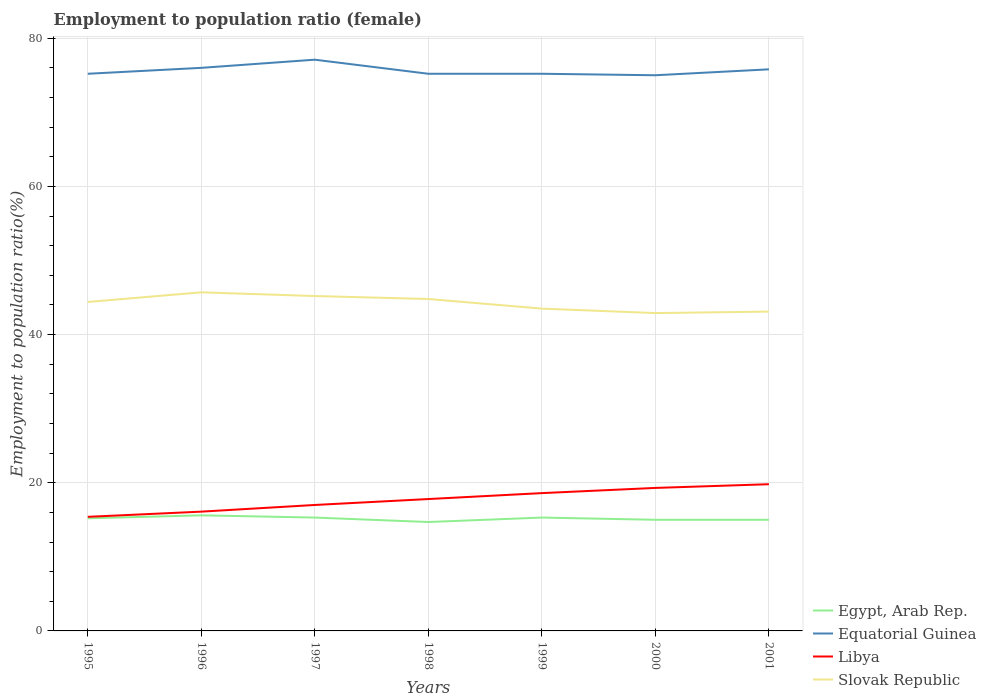How many different coloured lines are there?
Your answer should be compact. 4. Does the line corresponding to Slovak Republic intersect with the line corresponding to Equatorial Guinea?
Your response must be concise. No. Is the number of lines equal to the number of legend labels?
Your response must be concise. Yes. Across all years, what is the maximum employment to population ratio in Libya?
Keep it short and to the point. 15.4. In which year was the employment to population ratio in Libya maximum?
Ensure brevity in your answer.  1995. What is the total employment to population ratio in Equatorial Guinea in the graph?
Provide a succinct answer. 0.2. What is the difference between the highest and the second highest employment to population ratio in Egypt, Arab Rep.?
Your response must be concise. 0.9. What is the difference between the highest and the lowest employment to population ratio in Egypt, Arab Rep.?
Provide a short and direct response. 4. How many lines are there?
Your answer should be very brief. 4. What is the difference between two consecutive major ticks on the Y-axis?
Keep it short and to the point. 20. Are the values on the major ticks of Y-axis written in scientific E-notation?
Offer a very short reply. No. Does the graph contain grids?
Keep it short and to the point. Yes. Where does the legend appear in the graph?
Your answer should be compact. Bottom right. What is the title of the graph?
Your answer should be very brief. Employment to population ratio (female). What is the label or title of the X-axis?
Your answer should be very brief. Years. What is the Employment to population ratio(%) in Egypt, Arab Rep. in 1995?
Provide a short and direct response. 15.2. What is the Employment to population ratio(%) in Equatorial Guinea in 1995?
Provide a short and direct response. 75.2. What is the Employment to population ratio(%) in Libya in 1995?
Provide a short and direct response. 15.4. What is the Employment to population ratio(%) of Slovak Republic in 1995?
Offer a very short reply. 44.4. What is the Employment to population ratio(%) of Egypt, Arab Rep. in 1996?
Offer a very short reply. 15.6. What is the Employment to population ratio(%) in Libya in 1996?
Ensure brevity in your answer.  16.1. What is the Employment to population ratio(%) of Slovak Republic in 1996?
Your response must be concise. 45.7. What is the Employment to population ratio(%) in Egypt, Arab Rep. in 1997?
Ensure brevity in your answer.  15.3. What is the Employment to population ratio(%) of Equatorial Guinea in 1997?
Your response must be concise. 77.1. What is the Employment to population ratio(%) of Slovak Republic in 1997?
Your response must be concise. 45.2. What is the Employment to population ratio(%) in Egypt, Arab Rep. in 1998?
Give a very brief answer. 14.7. What is the Employment to population ratio(%) of Equatorial Guinea in 1998?
Provide a short and direct response. 75.2. What is the Employment to population ratio(%) in Libya in 1998?
Your response must be concise. 17.8. What is the Employment to population ratio(%) in Slovak Republic in 1998?
Make the answer very short. 44.8. What is the Employment to population ratio(%) of Egypt, Arab Rep. in 1999?
Provide a short and direct response. 15.3. What is the Employment to population ratio(%) of Equatorial Guinea in 1999?
Your answer should be compact. 75.2. What is the Employment to population ratio(%) in Libya in 1999?
Your answer should be compact. 18.6. What is the Employment to population ratio(%) of Slovak Republic in 1999?
Offer a very short reply. 43.5. What is the Employment to population ratio(%) in Libya in 2000?
Provide a succinct answer. 19.3. What is the Employment to population ratio(%) of Slovak Republic in 2000?
Your answer should be very brief. 42.9. What is the Employment to population ratio(%) in Egypt, Arab Rep. in 2001?
Offer a very short reply. 15. What is the Employment to population ratio(%) in Equatorial Guinea in 2001?
Make the answer very short. 75.8. What is the Employment to population ratio(%) in Libya in 2001?
Offer a very short reply. 19.8. What is the Employment to population ratio(%) in Slovak Republic in 2001?
Your answer should be very brief. 43.1. Across all years, what is the maximum Employment to population ratio(%) of Egypt, Arab Rep.?
Offer a very short reply. 15.6. Across all years, what is the maximum Employment to population ratio(%) in Equatorial Guinea?
Offer a terse response. 77.1. Across all years, what is the maximum Employment to population ratio(%) of Libya?
Give a very brief answer. 19.8. Across all years, what is the maximum Employment to population ratio(%) of Slovak Republic?
Provide a succinct answer. 45.7. Across all years, what is the minimum Employment to population ratio(%) of Egypt, Arab Rep.?
Make the answer very short. 14.7. Across all years, what is the minimum Employment to population ratio(%) in Equatorial Guinea?
Offer a very short reply. 75. Across all years, what is the minimum Employment to population ratio(%) in Libya?
Your answer should be compact. 15.4. Across all years, what is the minimum Employment to population ratio(%) in Slovak Republic?
Ensure brevity in your answer.  42.9. What is the total Employment to population ratio(%) in Egypt, Arab Rep. in the graph?
Provide a succinct answer. 106.1. What is the total Employment to population ratio(%) in Equatorial Guinea in the graph?
Make the answer very short. 529.5. What is the total Employment to population ratio(%) in Libya in the graph?
Provide a short and direct response. 124. What is the total Employment to population ratio(%) in Slovak Republic in the graph?
Make the answer very short. 309.6. What is the difference between the Employment to population ratio(%) of Egypt, Arab Rep. in 1995 and that in 1996?
Your response must be concise. -0.4. What is the difference between the Employment to population ratio(%) of Libya in 1995 and that in 1996?
Provide a succinct answer. -0.7. What is the difference between the Employment to population ratio(%) of Egypt, Arab Rep. in 1995 and that in 1997?
Give a very brief answer. -0.1. What is the difference between the Employment to population ratio(%) of Equatorial Guinea in 1995 and that in 1997?
Offer a very short reply. -1.9. What is the difference between the Employment to population ratio(%) in Libya in 1995 and that in 1997?
Ensure brevity in your answer.  -1.6. What is the difference between the Employment to population ratio(%) in Slovak Republic in 1995 and that in 1997?
Provide a succinct answer. -0.8. What is the difference between the Employment to population ratio(%) of Slovak Republic in 1995 and that in 1998?
Keep it short and to the point. -0.4. What is the difference between the Employment to population ratio(%) of Equatorial Guinea in 1995 and that in 1999?
Your response must be concise. 0. What is the difference between the Employment to population ratio(%) of Egypt, Arab Rep. in 1995 and that in 2000?
Offer a terse response. 0.2. What is the difference between the Employment to population ratio(%) in Equatorial Guinea in 1995 and that in 2000?
Give a very brief answer. 0.2. What is the difference between the Employment to population ratio(%) of Libya in 1995 and that in 2000?
Your answer should be compact. -3.9. What is the difference between the Employment to population ratio(%) in Slovak Republic in 1995 and that in 2000?
Keep it short and to the point. 1.5. What is the difference between the Employment to population ratio(%) of Equatorial Guinea in 1996 and that in 1997?
Ensure brevity in your answer.  -1.1. What is the difference between the Employment to population ratio(%) of Libya in 1996 and that in 1997?
Ensure brevity in your answer.  -0.9. What is the difference between the Employment to population ratio(%) in Slovak Republic in 1996 and that in 1997?
Your answer should be compact. 0.5. What is the difference between the Employment to population ratio(%) in Egypt, Arab Rep. in 1996 and that in 1998?
Offer a terse response. 0.9. What is the difference between the Employment to population ratio(%) in Equatorial Guinea in 1996 and that in 1998?
Make the answer very short. 0.8. What is the difference between the Employment to population ratio(%) of Libya in 1996 and that in 1999?
Your response must be concise. -2.5. What is the difference between the Employment to population ratio(%) of Slovak Republic in 1996 and that in 1999?
Provide a short and direct response. 2.2. What is the difference between the Employment to population ratio(%) in Egypt, Arab Rep. in 1996 and that in 2000?
Provide a succinct answer. 0.6. What is the difference between the Employment to population ratio(%) in Libya in 1996 and that in 2000?
Your response must be concise. -3.2. What is the difference between the Employment to population ratio(%) of Slovak Republic in 1996 and that in 2000?
Give a very brief answer. 2.8. What is the difference between the Employment to population ratio(%) in Egypt, Arab Rep. in 1996 and that in 2001?
Offer a terse response. 0.6. What is the difference between the Employment to population ratio(%) in Equatorial Guinea in 1996 and that in 2001?
Your answer should be very brief. 0.2. What is the difference between the Employment to population ratio(%) of Libya in 1996 and that in 2001?
Provide a succinct answer. -3.7. What is the difference between the Employment to population ratio(%) in Equatorial Guinea in 1997 and that in 1998?
Your response must be concise. 1.9. What is the difference between the Employment to population ratio(%) in Equatorial Guinea in 1997 and that in 1999?
Offer a very short reply. 1.9. What is the difference between the Employment to population ratio(%) in Libya in 1997 and that in 2000?
Offer a terse response. -2.3. What is the difference between the Employment to population ratio(%) of Slovak Republic in 1997 and that in 2000?
Ensure brevity in your answer.  2.3. What is the difference between the Employment to population ratio(%) of Equatorial Guinea in 1997 and that in 2001?
Your response must be concise. 1.3. What is the difference between the Employment to population ratio(%) in Egypt, Arab Rep. in 1998 and that in 1999?
Keep it short and to the point. -0.6. What is the difference between the Employment to population ratio(%) in Equatorial Guinea in 1998 and that in 1999?
Keep it short and to the point. 0. What is the difference between the Employment to population ratio(%) of Slovak Republic in 1998 and that in 2000?
Provide a succinct answer. 1.9. What is the difference between the Employment to population ratio(%) in Equatorial Guinea in 1998 and that in 2001?
Ensure brevity in your answer.  -0.6. What is the difference between the Employment to population ratio(%) of Libya in 1998 and that in 2001?
Your answer should be compact. -2. What is the difference between the Employment to population ratio(%) in Egypt, Arab Rep. in 1999 and that in 2000?
Ensure brevity in your answer.  0.3. What is the difference between the Employment to population ratio(%) in Equatorial Guinea in 1999 and that in 2000?
Offer a very short reply. 0.2. What is the difference between the Employment to population ratio(%) in Libya in 1999 and that in 2001?
Keep it short and to the point. -1.2. What is the difference between the Employment to population ratio(%) of Slovak Republic in 1999 and that in 2001?
Your response must be concise. 0.4. What is the difference between the Employment to population ratio(%) in Egypt, Arab Rep. in 2000 and that in 2001?
Your response must be concise. 0. What is the difference between the Employment to population ratio(%) in Equatorial Guinea in 2000 and that in 2001?
Provide a short and direct response. -0.8. What is the difference between the Employment to population ratio(%) of Slovak Republic in 2000 and that in 2001?
Offer a very short reply. -0.2. What is the difference between the Employment to population ratio(%) in Egypt, Arab Rep. in 1995 and the Employment to population ratio(%) in Equatorial Guinea in 1996?
Keep it short and to the point. -60.8. What is the difference between the Employment to population ratio(%) of Egypt, Arab Rep. in 1995 and the Employment to population ratio(%) of Slovak Republic in 1996?
Provide a short and direct response. -30.5. What is the difference between the Employment to population ratio(%) in Equatorial Guinea in 1995 and the Employment to population ratio(%) in Libya in 1996?
Keep it short and to the point. 59.1. What is the difference between the Employment to population ratio(%) in Equatorial Guinea in 1995 and the Employment to population ratio(%) in Slovak Republic in 1996?
Provide a succinct answer. 29.5. What is the difference between the Employment to population ratio(%) of Libya in 1995 and the Employment to population ratio(%) of Slovak Republic in 1996?
Offer a terse response. -30.3. What is the difference between the Employment to population ratio(%) in Egypt, Arab Rep. in 1995 and the Employment to population ratio(%) in Equatorial Guinea in 1997?
Offer a very short reply. -61.9. What is the difference between the Employment to population ratio(%) of Egypt, Arab Rep. in 1995 and the Employment to population ratio(%) of Slovak Republic in 1997?
Provide a short and direct response. -30. What is the difference between the Employment to population ratio(%) of Equatorial Guinea in 1995 and the Employment to population ratio(%) of Libya in 1997?
Ensure brevity in your answer.  58.2. What is the difference between the Employment to population ratio(%) in Libya in 1995 and the Employment to population ratio(%) in Slovak Republic in 1997?
Give a very brief answer. -29.8. What is the difference between the Employment to population ratio(%) in Egypt, Arab Rep. in 1995 and the Employment to population ratio(%) in Equatorial Guinea in 1998?
Give a very brief answer. -60. What is the difference between the Employment to population ratio(%) of Egypt, Arab Rep. in 1995 and the Employment to population ratio(%) of Slovak Republic in 1998?
Give a very brief answer. -29.6. What is the difference between the Employment to population ratio(%) of Equatorial Guinea in 1995 and the Employment to population ratio(%) of Libya in 1998?
Your response must be concise. 57.4. What is the difference between the Employment to population ratio(%) of Equatorial Guinea in 1995 and the Employment to population ratio(%) of Slovak Republic in 1998?
Your answer should be compact. 30.4. What is the difference between the Employment to population ratio(%) in Libya in 1995 and the Employment to population ratio(%) in Slovak Republic in 1998?
Provide a short and direct response. -29.4. What is the difference between the Employment to population ratio(%) of Egypt, Arab Rep. in 1995 and the Employment to population ratio(%) of Equatorial Guinea in 1999?
Offer a terse response. -60. What is the difference between the Employment to population ratio(%) in Egypt, Arab Rep. in 1995 and the Employment to population ratio(%) in Slovak Republic in 1999?
Ensure brevity in your answer.  -28.3. What is the difference between the Employment to population ratio(%) of Equatorial Guinea in 1995 and the Employment to population ratio(%) of Libya in 1999?
Make the answer very short. 56.6. What is the difference between the Employment to population ratio(%) of Equatorial Guinea in 1995 and the Employment to population ratio(%) of Slovak Republic in 1999?
Give a very brief answer. 31.7. What is the difference between the Employment to population ratio(%) in Libya in 1995 and the Employment to population ratio(%) in Slovak Republic in 1999?
Ensure brevity in your answer.  -28.1. What is the difference between the Employment to population ratio(%) in Egypt, Arab Rep. in 1995 and the Employment to population ratio(%) in Equatorial Guinea in 2000?
Give a very brief answer. -59.8. What is the difference between the Employment to population ratio(%) of Egypt, Arab Rep. in 1995 and the Employment to population ratio(%) of Slovak Republic in 2000?
Your answer should be very brief. -27.7. What is the difference between the Employment to population ratio(%) in Equatorial Guinea in 1995 and the Employment to population ratio(%) in Libya in 2000?
Your answer should be very brief. 55.9. What is the difference between the Employment to population ratio(%) of Equatorial Guinea in 1995 and the Employment to population ratio(%) of Slovak Republic in 2000?
Your response must be concise. 32.3. What is the difference between the Employment to population ratio(%) of Libya in 1995 and the Employment to population ratio(%) of Slovak Republic in 2000?
Provide a succinct answer. -27.5. What is the difference between the Employment to population ratio(%) in Egypt, Arab Rep. in 1995 and the Employment to population ratio(%) in Equatorial Guinea in 2001?
Provide a short and direct response. -60.6. What is the difference between the Employment to population ratio(%) in Egypt, Arab Rep. in 1995 and the Employment to population ratio(%) in Libya in 2001?
Your answer should be very brief. -4.6. What is the difference between the Employment to population ratio(%) in Egypt, Arab Rep. in 1995 and the Employment to population ratio(%) in Slovak Republic in 2001?
Offer a terse response. -27.9. What is the difference between the Employment to population ratio(%) in Equatorial Guinea in 1995 and the Employment to population ratio(%) in Libya in 2001?
Provide a short and direct response. 55.4. What is the difference between the Employment to population ratio(%) in Equatorial Guinea in 1995 and the Employment to population ratio(%) in Slovak Republic in 2001?
Offer a terse response. 32.1. What is the difference between the Employment to population ratio(%) in Libya in 1995 and the Employment to population ratio(%) in Slovak Republic in 2001?
Your answer should be compact. -27.7. What is the difference between the Employment to population ratio(%) in Egypt, Arab Rep. in 1996 and the Employment to population ratio(%) in Equatorial Guinea in 1997?
Provide a succinct answer. -61.5. What is the difference between the Employment to population ratio(%) in Egypt, Arab Rep. in 1996 and the Employment to population ratio(%) in Slovak Republic in 1997?
Keep it short and to the point. -29.6. What is the difference between the Employment to population ratio(%) in Equatorial Guinea in 1996 and the Employment to population ratio(%) in Slovak Republic in 1997?
Your answer should be compact. 30.8. What is the difference between the Employment to population ratio(%) in Libya in 1996 and the Employment to population ratio(%) in Slovak Republic in 1997?
Make the answer very short. -29.1. What is the difference between the Employment to population ratio(%) in Egypt, Arab Rep. in 1996 and the Employment to population ratio(%) in Equatorial Guinea in 1998?
Make the answer very short. -59.6. What is the difference between the Employment to population ratio(%) of Egypt, Arab Rep. in 1996 and the Employment to population ratio(%) of Libya in 1998?
Your response must be concise. -2.2. What is the difference between the Employment to population ratio(%) in Egypt, Arab Rep. in 1996 and the Employment to population ratio(%) in Slovak Republic in 1998?
Give a very brief answer. -29.2. What is the difference between the Employment to population ratio(%) in Equatorial Guinea in 1996 and the Employment to population ratio(%) in Libya in 1998?
Your answer should be very brief. 58.2. What is the difference between the Employment to population ratio(%) in Equatorial Guinea in 1996 and the Employment to population ratio(%) in Slovak Republic in 1998?
Ensure brevity in your answer.  31.2. What is the difference between the Employment to population ratio(%) of Libya in 1996 and the Employment to population ratio(%) of Slovak Republic in 1998?
Your response must be concise. -28.7. What is the difference between the Employment to population ratio(%) in Egypt, Arab Rep. in 1996 and the Employment to population ratio(%) in Equatorial Guinea in 1999?
Ensure brevity in your answer.  -59.6. What is the difference between the Employment to population ratio(%) of Egypt, Arab Rep. in 1996 and the Employment to population ratio(%) of Libya in 1999?
Offer a terse response. -3. What is the difference between the Employment to population ratio(%) of Egypt, Arab Rep. in 1996 and the Employment to population ratio(%) of Slovak Republic in 1999?
Your answer should be very brief. -27.9. What is the difference between the Employment to population ratio(%) in Equatorial Guinea in 1996 and the Employment to population ratio(%) in Libya in 1999?
Provide a succinct answer. 57.4. What is the difference between the Employment to population ratio(%) in Equatorial Guinea in 1996 and the Employment to population ratio(%) in Slovak Republic in 1999?
Your answer should be very brief. 32.5. What is the difference between the Employment to population ratio(%) in Libya in 1996 and the Employment to population ratio(%) in Slovak Republic in 1999?
Your answer should be compact. -27.4. What is the difference between the Employment to population ratio(%) in Egypt, Arab Rep. in 1996 and the Employment to population ratio(%) in Equatorial Guinea in 2000?
Offer a very short reply. -59.4. What is the difference between the Employment to population ratio(%) of Egypt, Arab Rep. in 1996 and the Employment to population ratio(%) of Slovak Republic in 2000?
Offer a very short reply. -27.3. What is the difference between the Employment to population ratio(%) in Equatorial Guinea in 1996 and the Employment to population ratio(%) in Libya in 2000?
Your response must be concise. 56.7. What is the difference between the Employment to population ratio(%) of Equatorial Guinea in 1996 and the Employment to population ratio(%) of Slovak Republic in 2000?
Ensure brevity in your answer.  33.1. What is the difference between the Employment to population ratio(%) in Libya in 1996 and the Employment to population ratio(%) in Slovak Republic in 2000?
Keep it short and to the point. -26.8. What is the difference between the Employment to population ratio(%) in Egypt, Arab Rep. in 1996 and the Employment to population ratio(%) in Equatorial Guinea in 2001?
Make the answer very short. -60.2. What is the difference between the Employment to population ratio(%) in Egypt, Arab Rep. in 1996 and the Employment to population ratio(%) in Slovak Republic in 2001?
Make the answer very short. -27.5. What is the difference between the Employment to population ratio(%) of Equatorial Guinea in 1996 and the Employment to population ratio(%) of Libya in 2001?
Give a very brief answer. 56.2. What is the difference between the Employment to population ratio(%) of Equatorial Guinea in 1996 and the Employment to population ratio(%) of Slovak Republic in 2001?
Offer a very short reply. 32.9. What is the difference between the Employment to population ratio(%) of Libya in 1996 and the Employment to population ratio(%) of Slovak Republic in 2001?
Make the answer very short. -27. What is the difference between the Employment to population ratio(%) of Egypt, Arab Rep. in 1997 and the Employment to population ratio(%) of Equatorial Guinea in 1998?
Give a very brief answer. -59.9. What is the difference between the Employment to population ratio(%) in Egypt, Arab Rep. in 1997 and the Employment to population ratio(%) in Slovak Republic in 1998?
Offer a very short reply. -29.5. What is the difference between the Employment to population ratio(%) in Equatorial Guinea in 1997 and the Employment to population ratio(%) in Libya in 1998?
Provide a short and direct response. 59.3. What is the difference between the Employment to population ratio(%) in Equatorial Guinea in 1997 and the Employment to population ratio(%) in Slovak Republic in 1998?
Your answer should be compact. 32.3. What is the difference between the Employment to population ratio(%) in Libya in 1997 and the Employment to population ratio(%) in Slovak Republic in 1998?
Make the answer very short. -27.8. What is the difference between the Employment to population ratio(%) in Egypt, Arab Rep. in 1997 and the Employment to population ratio(%) in Equatorial Guinea in 1999?
Your response must be concise. -59.9. What is the difference between the Employment to population ratio(%) of Egypt, Arab Rep. in 1997 and the Employment to population ratio(%) of Slovak Republic in 1999?
Your response must be concise. -28.2. What is the difference between the Employment to population ratio(%) of Equatorial Guinea in 1997 and the Employment to population ratio(%) of Libya in 1999?
Give a very brief answer. 58.5. What is the difference between the Employment to population ratio(%) of Equatorial Guinea in 1997 and the Employment to population ratio(%) of Slovak Republic in 1999?
Offer a very short reply. 33.6. What is the difference between the Employment to population ratio(%) of Libya in 1997 and the Employment to population ratio(%) of Slovak Republic in 1999?
Your response must be concise. -26.5. What is the difference between the Employment to population ratio(%) of Egypt, Arab Rep. in 1997 and the Employment to population ratio(%) of Equatorial Guinea in 2000?
Offer a terse response. -59.7. What is the difference between the Employment to population ratio(%) in Egypt, Arab Rep. in 1997 and the Employment to population ratio(%) in Libya in 2000?
Give a very brief answer. -4. What is the difference between the Employment to population ratio(%) of Egypt, Arab Rep. in 1997 and the Employment to population ratio(%) of Slovak Republic in 2000?
Offer a terse response. -27.6. What is the difference between the Employment to population ratio(%) of Equatorial Guinea in 1997 and the Employment to population ratio(%) of Libya in 2000?
Your answer should be compact. 57.8. What is the difference between the Employment to population ratio(%) in Equatorial Guinea in 1997 and the Employment to population ratio(%) in Slovak Republic in 2000?
Offer a terse response. 34.2. What is the difference between the Employment to population ratio(%) of Libya in 1997 and the Employment to population ratio(%) of Slovak Republic in 2000?
Your answer should be very brief. -25.9. What is the difference between the Employment to population ratio(%) in Egypt, Arab Rep. in 1997 and the Employment to population ratio(%) in Equatorial Guinea in 2001?
Provide a short and direct response. -60.5. What is the difference between the Employment to population ratio(%) in Egypt, Arab Rep. in 1997 and the Employment to population ratio(%) in Libya in 2001?
Keep it short and to the point. -4.5. What is the difference between the Employment to population ratio(%) in Egypt, Arab Rep. in 1997 and the Employment to population ratio(%) in Slovak Republic in 2001?
Ensure brevity in your answer.  -27.8. What is the difference between the Employment to population ratio(%) of Equatorial Guinea in 1997 and the Employment to population ratio(%) of Libya in 2001?
Offer a terse response. 57.3. What is the difference between the Employment to population ratio(%) in Libya in 1997 and the Employment to population ratio(%) in Slovak Republic in 2001?
Give a very brief answer. -26.1. What is the difference between the Employment to population ratio(%) in Egypt, Arab Rep. in 1998 and the Employment to population ratio(%) in Equatorial Guinea in 1999?
Offer a terse response. -60.5. What is the difference between the Employment to population ratio(%) in Egypt, Arab Rep. in 1998 and the Employment to population ratio(%) in Slovak Republic in 1999?
Offer a terse response. -28.8. What is the difference between the Employment to population ratio(%) in Equatorial Guinea in 1998 and the Employment to population ratio(%) in Libya in 1999?
Offer a very short reply. 56.6. What is the difference between the Employment to population ratio(%) in Equatorial Guinea in 1998 and the Employment to population ratio(%) in Slovak Republic in 1999?
Ensure brevity in your answer.  31.7. What is the difference between the Employment to population ratio(%) in Libya in 1998 and the Employment to population ratio(%) in Slovak Republic in 1999?
Keep it short and to the point. -25.7. What is the difference between the Employment to population ratio(%) of Egypt, Arab Rep. in 1998 and the Employment to population ratio(%) of Equatorial Guinea in 2000?
Provide a succinct answer. -60.3. What is the difference between the Employment to population ratio(%) in Egypt, Arab Rep. in 1998 and the Employment to population ratio(%) in Slovak Republic in 2000?
Give a very brief answer. -28.2. What is the difference between the Employment to population ratio(%) of Equatorial Guinea in 1998 and the Employment to population ratio(%) of Libya in 2000?
Keep it short and to the point. 55.9. What is the difference between the Employment to population ratio(%) of Equatorial Guinea in 1998 and the Employment to population ratio(%) of Slovak Republic in 2000?
Give a very brief answer. 32.3. What is the difference between the Employment to population ratio(%) in Libya in 1998 and the Employment to population ratio(%) in Slovak Republic in 2000?
Make the answer very short. -25.1. What is the difference between the Employment to population ratio(%) of Egypt, Arab Rep. in 1998 and the Employment to population ratio(%) of Equatorial Guinea in 2001?
Offer a very short reply. -61.1. What is the difference between the Employment to population ratio(%) of Egypt, Arab Rep. in 1998 and the Employment to population ratio(%) of Slovak Republic in 2001?
Provide a short and direct response. -28.4. What is the difference between the Employment to population ratio(%) of Equatorial Guinea in 1998 and the Employment to population ratio(%) of Libya in 2001?
Offer a terse response. 55.4. What is the difference between the Employment to population ratio(%) of Equatorial Guinea in 1998 and the Employment to population ratio(%) of Slovak Republic in 2001?
Offer a very short reply. 32.1. What is the difference between the Employment to population ratio(%) in Libya in 1998 and the Employment to population ratio(%) in Slovak Republic in 2001?
Give a very brief answer. -25.3. What is the difference between the Employment to population ratio(%) in Egypt, Arab Rep. in 1999 and the Employment to population ratio(%) in Equatorial Guinea in 2000?
Ensure brevity in your answer.  -59.7. What is the difference between the Employment to population ratio(%) of Egypt, Arab Rep. in 1999 and the Employment to population ratio(%) of Slovak Republic in 2000?
Offer a very short reply. -27.6. What is the difference between the Employment to population ratio(%) of Equatorial Guinea in 1999 and the Employment to population ratio(%) of Libya in 2000?
Give a very brief answer. 55.9. What is the difference between the Employment to population ratio(%) in Equatorial Guinea in 1999 and the Employment to population ratio(%) in Slovak Republic in 2000?
Your response must be concise. 32.3. What is the difference between the Employment to population ratio(%) of Libya in 1999 and the Employment to population ratio(%) of Slovak Republic in 2000?
Keep it short and to the point. -24.3. What is the difference between the Employment to population ratio(%) in Egypt, Arab Rep. in 1999 and the Employment to population ratio(%) in Equatorial Guinea in 2001?
Provide a short and direct response. -60.5. What is the difference between the Employment to population ratio(%) in Egypt, Arab Rep. in 1999 and the Employment to population ratio(%) in Slovak Republic in 2001?
Your answer should be compact. -27.8. What is the difference between the Employment to population ratio(%) of Equatorial Guinea in 1999 and the Employment to population ratio(%) of Libya in 2001?
Your response must be concise. 55.4. What is the difference between the Employment to population ratio(%) in Equatorial Guinea in 1999 and the Employment to population ratio(%) in Slovak Republic in 2001?
Give a very brief answer. 32.1. What is the difference between the Employment to population ratio(%) of Libya in 1999 and the Employment to population ratio(%) of Slovak Republic in 2001?
Provide a succinct answer. -24.5. What is the difference between the Employment to population ratio(%) of Egypt, Arab Rep. in 2000 and the Employment to population ratio(%) of Equatorial Guinea in 2001?
Make the answer very short. -60.8. What is the difference between the Employment to population ratio(%) in Egypt, Arab Rep. in 2000 and the Employment to population ratio(%) in Libya in 2001?
Your answer should be compact. -4.8. What is the difference between the Employment to population ratio(%) in Egypt, Arab Rep. in 2000 and the Employment to population ratio(%) in Slovak Republic in 2001?
Your response must be concise. -28.1. What is the difference between the Employment to population ratio(%) of Equatorial Guinea in 2000 and the Employment to population ratio(%) of Libya in 2001?
Provide a succinct answer. 55.2. What is the difference between the Employment to population ratio(%) of Equatorial Guinea in 2000 and the Employment to population ratio(%) of Slovak Republic in 2001?
Keep it short and to the point. 31.9. What is the difference between the Employment to population ratio(%) in Libya in 2000 and the Employment to population ratio(%) in Slovak Republic in 2001?
Your answer should be compact. -23.8. What is the average Employment to population ratio(%) in Egypt, Arab Rep. per year?
Your response must be concise. 15.16. What is the average Employment to population ratio(%) in Equatorial Guinea per year?
Give a very brief answer. 75.64. What is the average Employment to population ratio(%) in Libya per year?
Provide a succinct answer. 17.71. What is the average Employment to population ratio(%) of Slovak Republic per year?
Keep it short and to the point. 44.23. In the year 1995, what is the difference between the Employment to population ratio(%) of Egypt, Arab Rep. and Employment to population ratio(%) of Equatorial Guinea?
Provide a short and direct response. -60. In the year 1995, what is the difference between the Employment to population ratio(%) in Egypt, Arab Rep. and Employment to population ratio(%) in Libya?
Your answer should be compact. -0.2. In the year 1995, what is the difference between the Employment to population ratio(%) of Egypt, Arab Rep. and Employment to population ratio(%) of Slovak Republic?
Your answer should be compact. -29.2. In the year 1995, what is the difference between the Employment to population ratio(%) of Equatorial Guinea and Employment to population ratio(%) of Libya?
Your answer should be very brief. 59.8. In the year 1995, what is the difference between the Employment to population ratio(%) in Equatorial Guinea and Employment to population ratio(%) in Slovak Republic?
Ensure brevity in your answer.  30.8. In the year 1995, what is the difference between the Employment to population ratio(%) of Libya and Employment to population ratio(%) of Slovak Republic?
Provide a short and direct response. -29. In the year 1996, what is the difference between the Employment to population ratio(%) in Egypt, Arab Rep. and Employment to population ratio(%) in Equatorial Guinea?
Provide a short and direct response. -60.4. In the year 1996, what is the difference between the Employment to population ratio(%) of Egypt, Arab Rep. and Employment to population ratio(%) of Slovak Republic?
Offer a terse response. -30.1. In the year 1996, what is the difference between the Employment to population ratio(%) of Equatorial Guinea and Employment to population ratio(%) of Libya?
Offer a terse response. 59.9. In the year 1996, what is the difference between the Employment to population ratio(%) of Equatorial Guinea and Employment to population ratio(%) of Slovak Republic?
Ensure brevity in your answer.  30.3. In the year 1996, what is the difference between the Employment to population ratio(%) in Libya and Employment to population ratio(%) in Slovak Republic?
Ensure brevity in your answer.  -29.6. In the year 1997, what is the difference between the Employment to population ratio(%) in Egypt, Arab Rep. and Employment to population ratio(%) in Equatorial Guinea?
Your response must be concise. -61.8. In the year 1997, what is the difference between the Employment to population ratio(%) in Egypt, Arab Rep. and Employment to population ratio(%) in Libya?
Offer a very short reply. -1.7. In the year 1997, what is the difference between the Employment to population ratio(%) of Egypt, Arab Rep. and Employment to population ratio(%) of Slovak Republic?
Make the answer very short. -29.9. In the year 1997, what is the difference between the Employment to population ratio(%) in Equatorial Guinea and Employment to population ratio(%) in Libya?
Ensure brevity in your answer.  60.1. In the year 1997, what is the difference between the Employment to population ratio(%) in Equatorial Guinea and Employment to population ratio(%) in Slovak Republic?
Offer a terse response. 31.9. In the year 1997, what is the difference between the Employment to population ratio(%) in Libya and Employment to population ratio(%) in Slovak Republic?
Offer a terse response. -28.2. In the year 1998, what is the difference between the Employment to population ratio(%) of Egypt, Arab Rep. and Employment to population ratio(%) of Equatorial Guinea?
Your response must be concise. -60.5. In the year 1998, what is the difference between the Employment to population ratio(%) in Egypt, Arab Rep. and Employment to population ratio(%) in Slovak Republic?
Offer a terse response. -30.1. In the year 1998, what is the difference between the Employment to population ratio(%) of Equatorial Guinea and Employment to population ratio(%) of Libya?
Make the answer very short. 57.4. In the year 1998, what is the difference between the Employment to population ratio(%) of Equatorial Guinea and Employment to population ratio(%) of Slovak Republic?
Your answer should be compact. 30.4. In the year 1998, what is the difference between the Employment to population ratio(%) of Libya and Employment to population ratio(%) of Slovak Republic?
Ensure brevity in your answer.  -27. In the year 1999, what is the difference between the Employment to population ratio(%) of Egypt, Arab Rep. and Employment to population ratio(%) of Equatorial Guinea?
Your answer should be compact. -59.9. In the year 1999, what is the difference between the Employment to population ratio(%) of Egypt, Arab Rep. and Employment to population ratio(%) of Slovak Republic?
Ensure brevity in your answer.  -28.2. In the year 1999, what is the difference between the Employment to population ratio(%) in Equatorial Guinea and Employment to population ratio(%) in Libya?
Keep it short and to the point. 56.6. In the year 1999, what is the difference between the Employment to population ratio(%) in Equatorial Guinea and Employment to population ratio(%) in Slovak Republic?
Offer a terse response. 31.7. In the year 1999, what is the difference between the Employment to population ratio(%) of Libya and Employment to population ratio(%) of Slovak Republic?
Your answer should be very brief. -24.9. In the year 2000, what is the difference between the Employment to population ratio(%) in Egypt, Arab Rep. and Employment to population ratio(%) in Equatorial Guinea?
Your answer should be very brief. -60. In the year 2000, what is the difference between the Employment to population ratio(%) in Egypt, Arab Rep. and Employment to population ratio(%) in Libya?
Provide a succinct answer. -4.3. In the year 2000, what is the difference between the Employment to population ratio(%) of Egypt, Arab Rep. and Employment to population ratio(%) of Slovak Republic?
Give a very brief answer. -27.9. In the year 2000, what is the difference between the Employment to population ratio(%) of Equatorial Guinea and Employment to population ratio(%) of Libya?
Your answer should be very brief. 55.7. In the year 2000, what is the difference between the Employment to population ratio(%) of Equatorial Guinea and Employment to population ratio(%) of Slovak Republic?
Give a very brief answer. 32.1. In the year 2000, what is the difference between the Employment to population ratio(%) in Libya and Employment to population ratio(%) in Slovak Republic?
Your response must be concise. -23.6. In the year 2001, what is the difference between the Employment to population ratio(%) in Egypt, Arab Rep. and Employment to population ratio(%) in Equatorial Guinea?
Your answer should be compact. -60.8. In the year 2001, what is the difference between the Employment to population ratio(%) of Egypt, Arab Rep. and Employment to population ratio(%) of Slovak Republic?
Offer a terse response. -28.1. In the year 2001, what is the difference between the Employment to population ratio(%) of Equatorial Guinea and Employment to population ratio(%) of Libya?
Provide a succinct answer. 56. In the year 2001, what is the difference between the Employment to population ratio(%) of Equatorial Guinea and Employment to population ratio(%) of Slovak Republic?
Keep it short and to the point. 32.7. In the year 2001, what is the difference between the Employment to population ratio(%) in Libya and Employment to population ratio(%) in Slovak Republic?
Your answer should be very brief. -23.3. What is the ratio of the Employment to population ratio(%) of Egypt, Arab Rep. in 1995 to that in 1996?
Make the answer very short. 0.97. What is the ratio of the Employment to population ratio(%) of Equatorial Guinea in 1995 to that in 1996?
Offer a very short reply. 0.99. What is the ratio of the Employment to population ratio(%) of Libya in 1995 to that in 1996?
Your response must be concise. 0.96. What is the ratio of the Employment to population ratio(%) in Slovak Republic in 1995 to that in 1996?
Your answer should be compact. 0.97. What is the ratio of the Employment to population ratio(%) of Egypt, Arab Rep. in 1995 to that in 1997?
Make the answer very short. 0.99. What is the ratio of the Employment to population ratio(%) in Equatorial Guinea in 1995 to that in 1997?
Offer a terse response. 0.98. What is the ratio of the Employment to population ratio(%) of Libya in 1995 to that in 1997?
Your answer should be compact. 0.91. What is the ratio of the Employment to population ratio(%) in Slovak Republic in 1995 to that in 1997?
Offer a very short reply. 0.98. What is the ratio of the Employment to population ratio(%) of Egypt, Arab Rep. in 1995 to that in 1998?
Your answer should be very brief. 1.03. What is the ratio of the Employment to population ratio(%) in Libya in 1995 to that in 1998?
Provide a short and direct response. 0.87. What is the ratio of the Employment to population ratio(%) of Egypt, Arab Rep. in 1995 to that in 1999?
Your response must be concise. 0.99. What is the ratio of the Employment to population ratio(%) of Equatorial Guinea in 1995 to that in 1999?
Ensure brevity in your answer.  1. What is the ratio of the Employment to population ratio(%) in Libya in 1995 to that in 1999?
Offer a terse response. 0.83. What is the ratio of the Employment to population ratio(%) in Slovak Republic in 1995 to that in 1999?
Ensure brevity in your answer.  1.02. What is the ratio of the Employment to population ratio(%) in Egypt, Arab Rep. in 1995 to that in 2000?
Your answer should be compact. 1.01. What is the ratio of the Employment to population ratio(%) in Libya in 1995 to that in 2000?
Make the answer very short. 0.8. What is the ratio of the Employment to population ratio(%) of Slovak Republic in 1995 to that in 2000?
Offer a terse response. 1.03. What is the ratio of the Employment to population ratio(%) in Egypt, Arab Rep. in 1995 to that in 2001?
Your answer should be compact. 1.01. What is the ratio of the Employment to population ratio(%) of Libya in 1995 to that in 2001?
Keep it short and to the point. 0.78. What is the ratio of the Employment to population ratio(%) in Slovak Republic in 1995 to that in 2001?
Ensure brevity in your answer.  1.03. What is the ratio of the Employment to population ratio(%) of Egypt, Arab Rep. in 1996 to that in 1997?
Offer a very short reply. 1.02. What is the ratio of the Employment to population ratio(%) of Equatorial Guinea in 1996 to that in 1997?
Offer a very short reply. 0.99. What is the ratio of the Employment to population ratio(%) of Libya in 1996 to that in 1997?
Keep it short and to the point. 0.95. What is the ratio of the Employment to population ratio(%) of Slovak Republic in 1996 to that in 1997?
Offer a very short reply. 1.01. What is the ratio of the Employment to population ratio(%) of Egypt, Arab Rep. in 1996 to that in 1998?
Your answer should be very brief. 1.06. What is the ratio of the Employment to population ratio(%) in Equatorial Guinea in 1996 to that in 1998?
Your response must be concise. 1.01. What is the ratio of the Employment to population ratio(%) of Libya in 1996 to that in 1998?
Keep it short and to the point. 0.9. What is the ratio of the Employment to population ratio(%) of Slovak Republic in 1996 to that in 1998?
Offer a terse response. 1.02. What is the ratio of the Employment to population ratio(%) in Egypt, Arab Rep. in 1996 to that in 1999?
Your answer should be compact. 1.02. What is the ratio of the Employment to population ratio(%) in Equatorial Guinea in 1996 to that in 1999?
Give a very brief answer. 1.01. What is the ratio of the Employment to population ratio(%) in Libya in 1996 to that in 1999?
Keep it short and to the point. 0.87. What is the ratio of the Employment to population ratio(%) in Slovak Republic in 1996 to that in 1999?
Your answer should be very brief. 1.05. What is the ratio of the Employment to population ratio(%) in Egypt, Arab Rep. in 1996 to that in 2000?
Your response must be concise. 1.04. What is the ratio of the Employment to population ratio(%) in Equatorial Guinea in 1996 to that in 2000?
Offer a terse response. 1.01. What is the ratio of the Employment to population ratio(%) of Libya in 1996 to that in 2000?
Ensure brevity in your answer.  0.83. What is the ratio of the Employment to population ratio(%) in Slovak Republic in 1996 to that in 2000?
Provide a short and direct response. 1.07. What is the ratio of the Employment to population ratio(%) in Libya in 1996 to that in 2001?
Offer a terse response. 0.81. What is the ratio of the Employment to population ratio(%) of Slovak Republic in 1996 to that in 2001?
Provide a succinct answer. 1.06. What is the ratio of the Employment to population ratio(%) of Egypt, Arab Rep. in 1997 to that in 1998?
Give a very brief answer. 1.04. What is the ratio of the Employment to population ratio(%) in Equatorial Guinea in 1997 to that in 1998?
Your answer should be very brief. 1.03. What is the ratio of the Employment to population ratio(%) of Libya in 1997 to that in 1998?
Your answer should be very brief. 0.96. What is the ratio of the Employment to population ratio(%) of Slovak Republic in 1997 to that in 1998?
Make the answer very short. 1.01. What is the ratio of the Employment to population ratio(%) of Equatorial Guinea in 1997 to that in 1999?
Provide a succinct answer. 1.03. What is the ratio of the Employment to population ratio(%) of Libya in 1997 to that in 1999?
Ensure brevity in your answer.  0.91. What is the ratio of the Employment to population ratio(%) in Slovak Republic in 1997 to that in 1999?
Give a very brief answer. 1.04. What is the ratio of the Employment to population ratio(%) of Egypt, Arab Rep. in 1997 to that in 2000?
Ensure brevity in your answer.  1.02. What is the ratio of the Employment to population ratio(%) of Equatorial Guinea in 1997 to that in 2000?
Keep it short and to the point. 1.03. What is the ratio of the Employment to population ratio(%) in Libya in 1997 to that in 2000?
Your answer should be very brief. 0.88. What is the ratio of the Employment to population ratio(%) in Slovak Republic in 1997 to that in 2000?
Provide a short and direct response. 1.05. What is the ratio of the Employment to population ratio(%) in Egypt, Arab Rep. in 1997 to that in 2001?
Keep it short and to the point. 1.02. What is the ratio of the Employment to population ratio(%) in Equatorial Guinea in 1997 to that in 2001?
Offer a terse response. 1.02. What is the ratio of the Employment to population ratio(%) of Libya in 1997 to that in 2001?
Give a very brief answer. 0.86. What is the ratio of the Employment to population ratio(%) in Slovak Republic in 1997 to that in 2001?
Offer a terse response. 1.05. What is the ratio of the Employment to population ratio(%) of Egypt, Arab Rep. in 1998 to that in 1999?
Provide a succinct answer. 0.96. What is the ratio of the Employment to population ratio(%) in Slovak Republic in 1998 to that in 1999?
Ensure brevity in your answer.  1.03. What is the ratio of the Employment to population ratio(%) of Egypt, Arab Rep. in 1998 to that in 2000?
Offer a terse response. 0.98. What is the ratio of the Employment to population ratio(%) of Libya in 1998 to that in 2000?
Make the answer very short. 0.92. What is the ratio of the Employment to population ratio(%) of Slovak Republic in 1998 to that in 2000?
Give a very brief answer. 1.04. What is the ratio of the Employment to population ratio(%) of Egypt, Arab Rep. in 1998 to that in 2001?
Provide a short and direct response. 0.98. What is the ratio of the Employment to population ratio(%) of Libya in 1998 to that in 2001?
Offer a very short reply. 0.9. What is the ratio of the Employment to population ratio(%) in Slovak Republic in 1998 to that in 2001?
Offer a terse response. 1.04. What is the ratio of the Employment to population ratio(%) in Egypt, Arab Rep. in 1999 to that in 2000?
Make the answer very short. 1.02. What is the ratio of the Employment to population ratio(%) in Libya in 1999 to that in 2000?
Provide a short and direct response. 0.96. What is the ratio of the Employment to population ratio(%) in Slovak Republic in 1999 to that in 2000?
Provide a succinct answer. 1.01. What is the ratio of the Employment to population ratio(%) in Equatorial Guinea in 1999 to that in 2001?
Your answer should be compact. 0.99. What is the ratio of the Employment to population ratio(%) in Libya in 1999 to that in 2001?
Your response must be concise. 0.94. What is the ratio of the Employment to population ratio(%) of Slovak Republic in 1999 to that in 2001?
Offer a terse response. 1.01. What is the ratio of the Employment to population ratio(%) of Egypt, Arab Rep. in 2000 to that in 2001?
Offer a very short reply. 1. What is the ratio of the Employment to population ratio(%) of Libya in 2000 to that in 2001?
Your answer should be compact. 0.97. What is the difference between the highest and the second highest Employment to population ratio(%) in Egypt, Arab Rep.?
Your answer should be very brief. 0.3. What is the difference between the highest and the second highest Employment to population ratio(%) of Libya?
Ensure brevity in your answer.  0.5. What is the difference between the highest and the lowest Employment to population ratio(%) of Egypt, Arab Rep.?
Your answer should be compact. 0.9. What is the difference between the highest and the lowest Employment to population ratio(%) in Equatorial Guinea?
Provide a succinct answer. 2.1. What is the difference between the highest and the lowest Employment to population ratio(%) in Libya?
Your answer should be very brief. 4.4. 